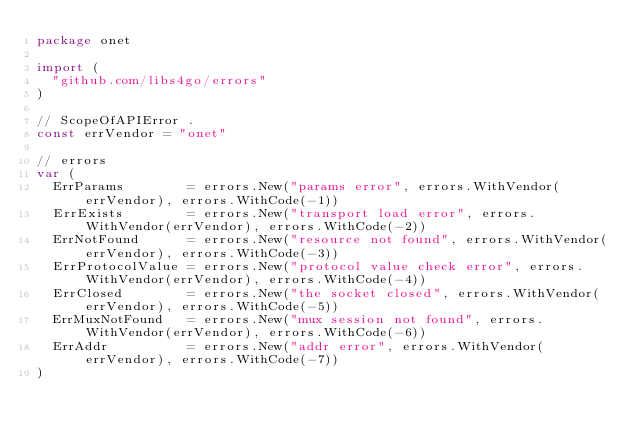Convert code to text. <code><loc_0><loc_0><loc_500><loc_500><_Go_>package onet

import (
	"github.com/libs4go/errors"
)

// ScopeOfAPIError .
const errVendor = "onet"

// errors
var (
	ErrParams        = errors.New("params error", errors.WithVendor(errVendor), errors.WithCode(-1))
	ErrExists        = errors.New("transport load error", errors.WithVendor(errVendor), errors.WithCode(-2))
	ErrNotFound      = errors.New("resource not found", errors.WithVendor(errVendor), errors.WithCode(-3))
	ErrProtocolValue = errors.New("protocol value check error", errors.WithVendor(errVendor), errors.WithCode(-4))
	ErrClosed        = errors.New("the socket closed", errors.WithVendor(errVendor), errors.WithCode(-5))
	ErrMuxNotFound   = errors.New("mux session not found", errors.WithVendor(errVendor), errors.WithCode(-6))
	ErrAddr          = errors.New("addr error", errors.WithVendor(errVendor), errors.WithCode(-7))
)
</code> 